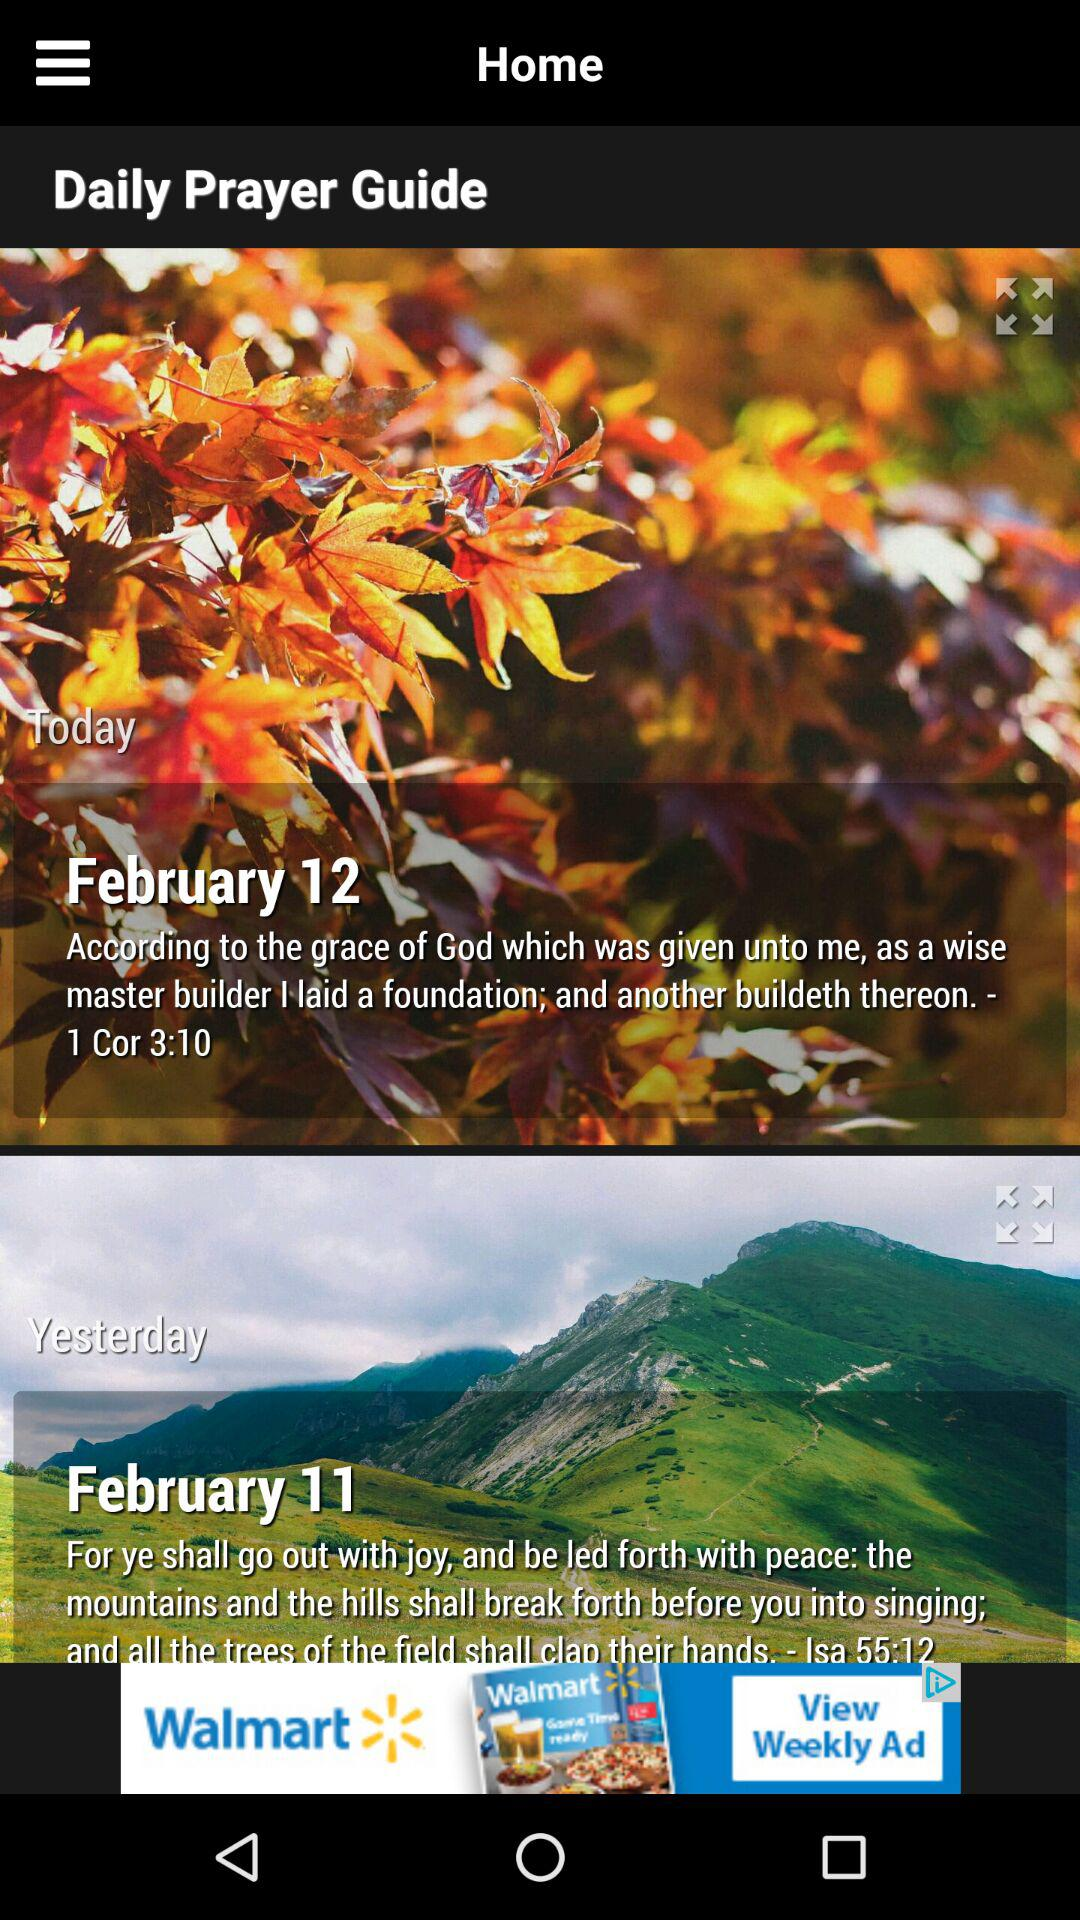How many verses are there in total on this screen?
Answer the question using a single word or phrase. 2 